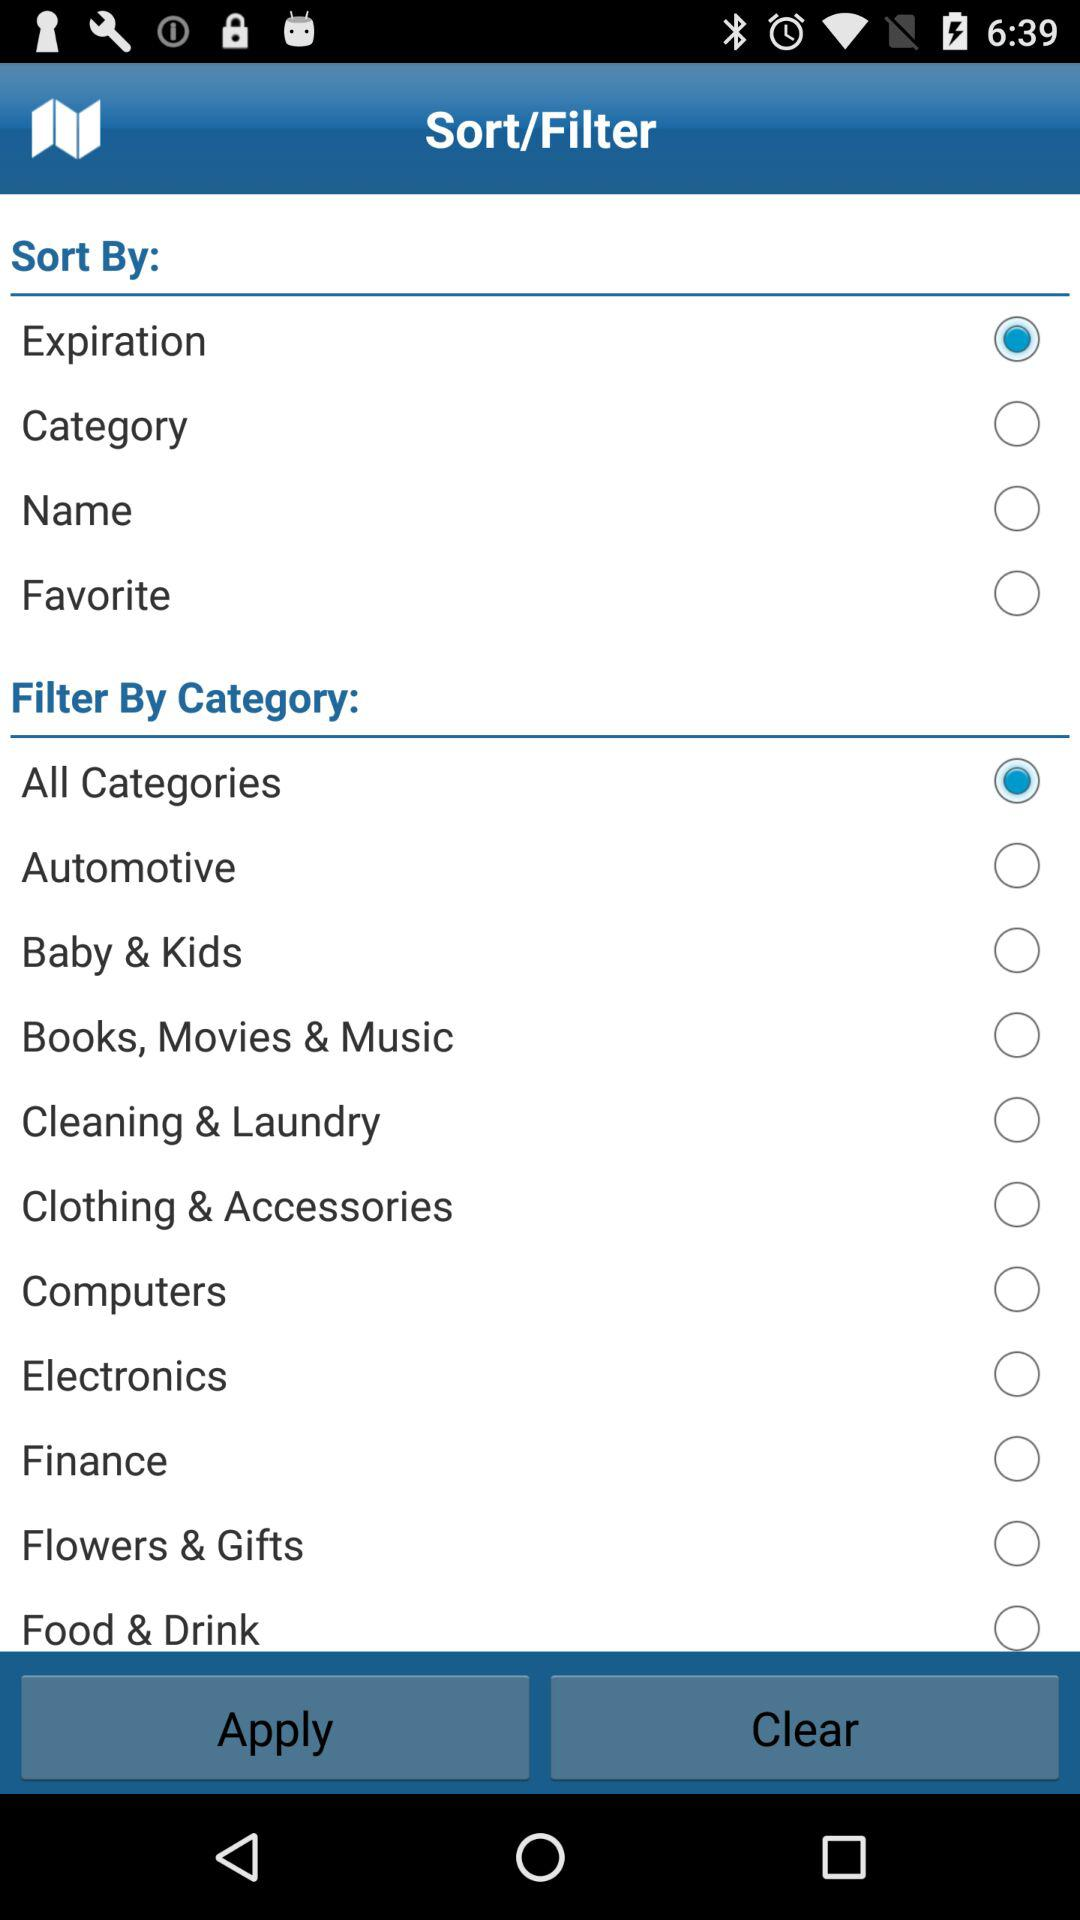What is the filter category selected? The filter category selected is "All Categories". 